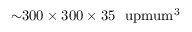<formula> <loc_0><loc_0><loc_500><loc_500>{ \sim } 3 0 0 \times 3 0 0 \times 3 5 \ u p m u m ^ { 3 }</formula> 